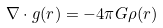<formula> <loc_0><loc_0><loc_500><loc_500>\nabla \cdot g ( r ) = - 4 \pi G \rho ( r )</formula> 